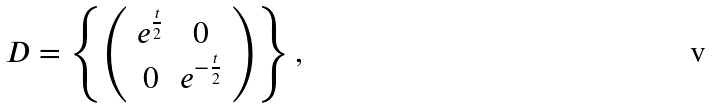Convert formula to latex. <formula><loc_0><loc_0><loc_500><loc_500>D = \left \{ \left ( \begin{array} { c c } e ^ { \frac { t } { 2 } } & 0 \\ 0 & e ^ { - \frac { t } { 2 } } \end{array} \right ) \right \} ,</formula> 